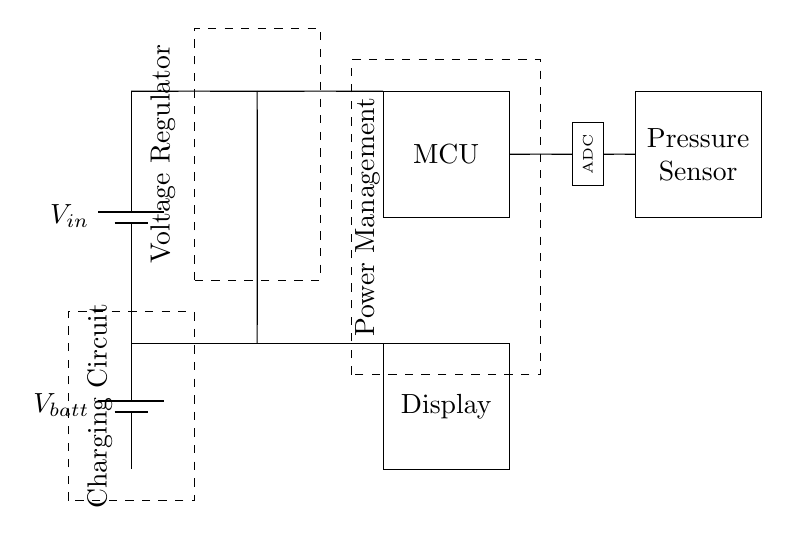What type of voltage regulator is used? The circuit does not specify a particular type, but indicates that a voltage regulator is present, which suggests it could be linear or switching, depending on the application.
Answer: Voltage regulator What does the battery provide? The battery provides an alternative power source for the circuit, specifically labeled as V_batt. This allows for portable operation of the device.
Answer: V_batt What is connected to the microcontroller? The microcontroller is connected to a sensor on one side and an ADC (Analog-to-Digital Converter) on the other, indicating that it processes input from the sensor.
Answer: Pressure sensor and ADC How is the charging circuit indicated? The charging circuit is indicated by the dashed rectangle encompassing it, showing it is a distinct functionality for maintaining battery charge.
Answer: Dashed rectangle What is the primary function of the ADC in this circuit? The ADC's primary function is to convert the analog signal from the pressure sensor into a digital signal that the microcontroller can process for further analysis.
Answer: Conversion What role does the display have in this circuit? The display shows the output data processed by the microcontroller, such as the blood pressure readings, making it essential for user interaction.
Answer: Visual output What is the overall purpose of the power management section? The power management section regulates voltage and current to ensure that the device operates efficiently and safely, especially when powered by the battery.
Answer: Power regulation 